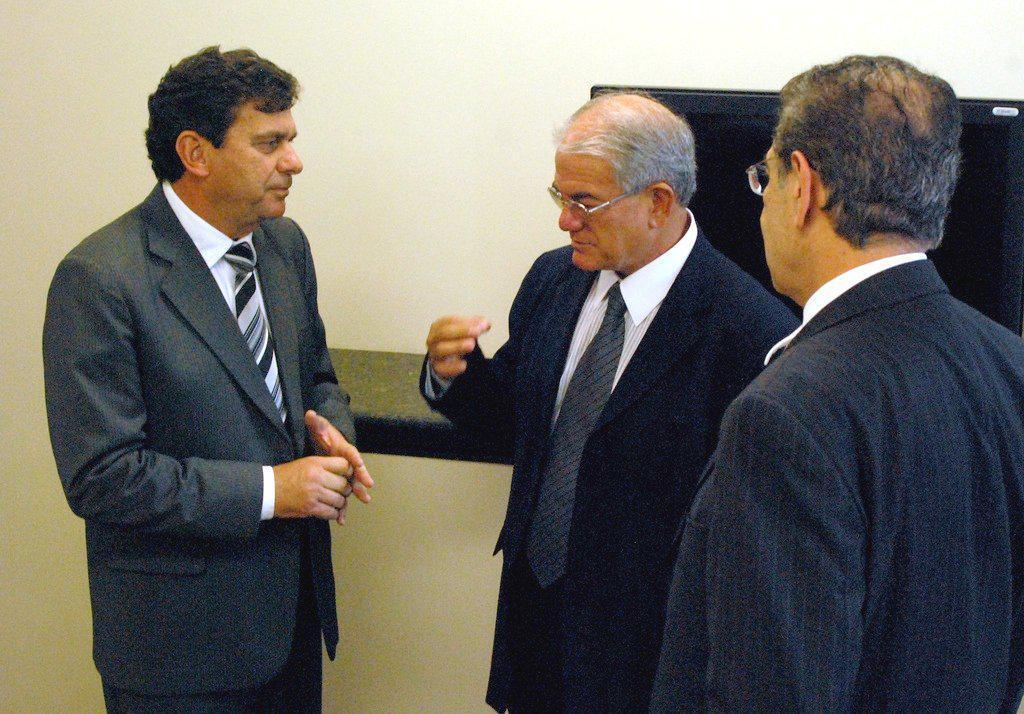In one or two sentences, can you explain what this image depicts? There are men standing in the foreground area of the image, it seems like a screen on a desk in the background. 